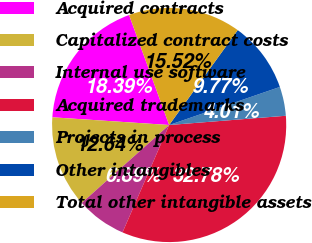Convert chart. <chart><loc_0><loc_0><loc_500><loc_500><pie_chart><fcel>Acquired contracts<fcel>Capitalized contract costs<fcel>Internal use software<fcel>Acquired trademarks<fcel>Projects in process<fcel>Other intangibles<fcel>Total other intangible assets<nl><fcel>18.39%<fcel>12.64%<fcel>6.89%<fcel>32.78%<fcel>4.01%<fcel>9.77%<fcel>15.52%<nl></chart> 